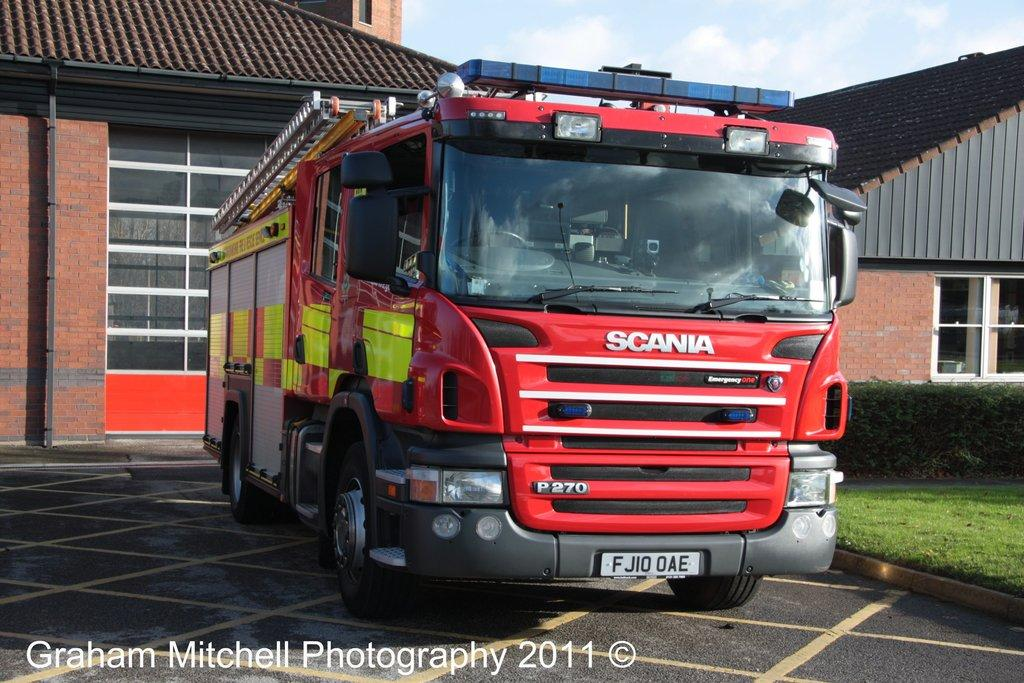What type of structures can be seen in the image? There are houses in the image. What feature is common to the houses in the image? There are windows in the image. What mode of transportation is present in the image? There is a red color truck in the image. What type of natural environment is visible in the image? There is grass visible in the image. What part of the natural environment is visible in the image? The sky is visible in the image. How does the stove produce steam in the image? There is no stove present in the image, so it is not possible to determine how steam might be produced. 